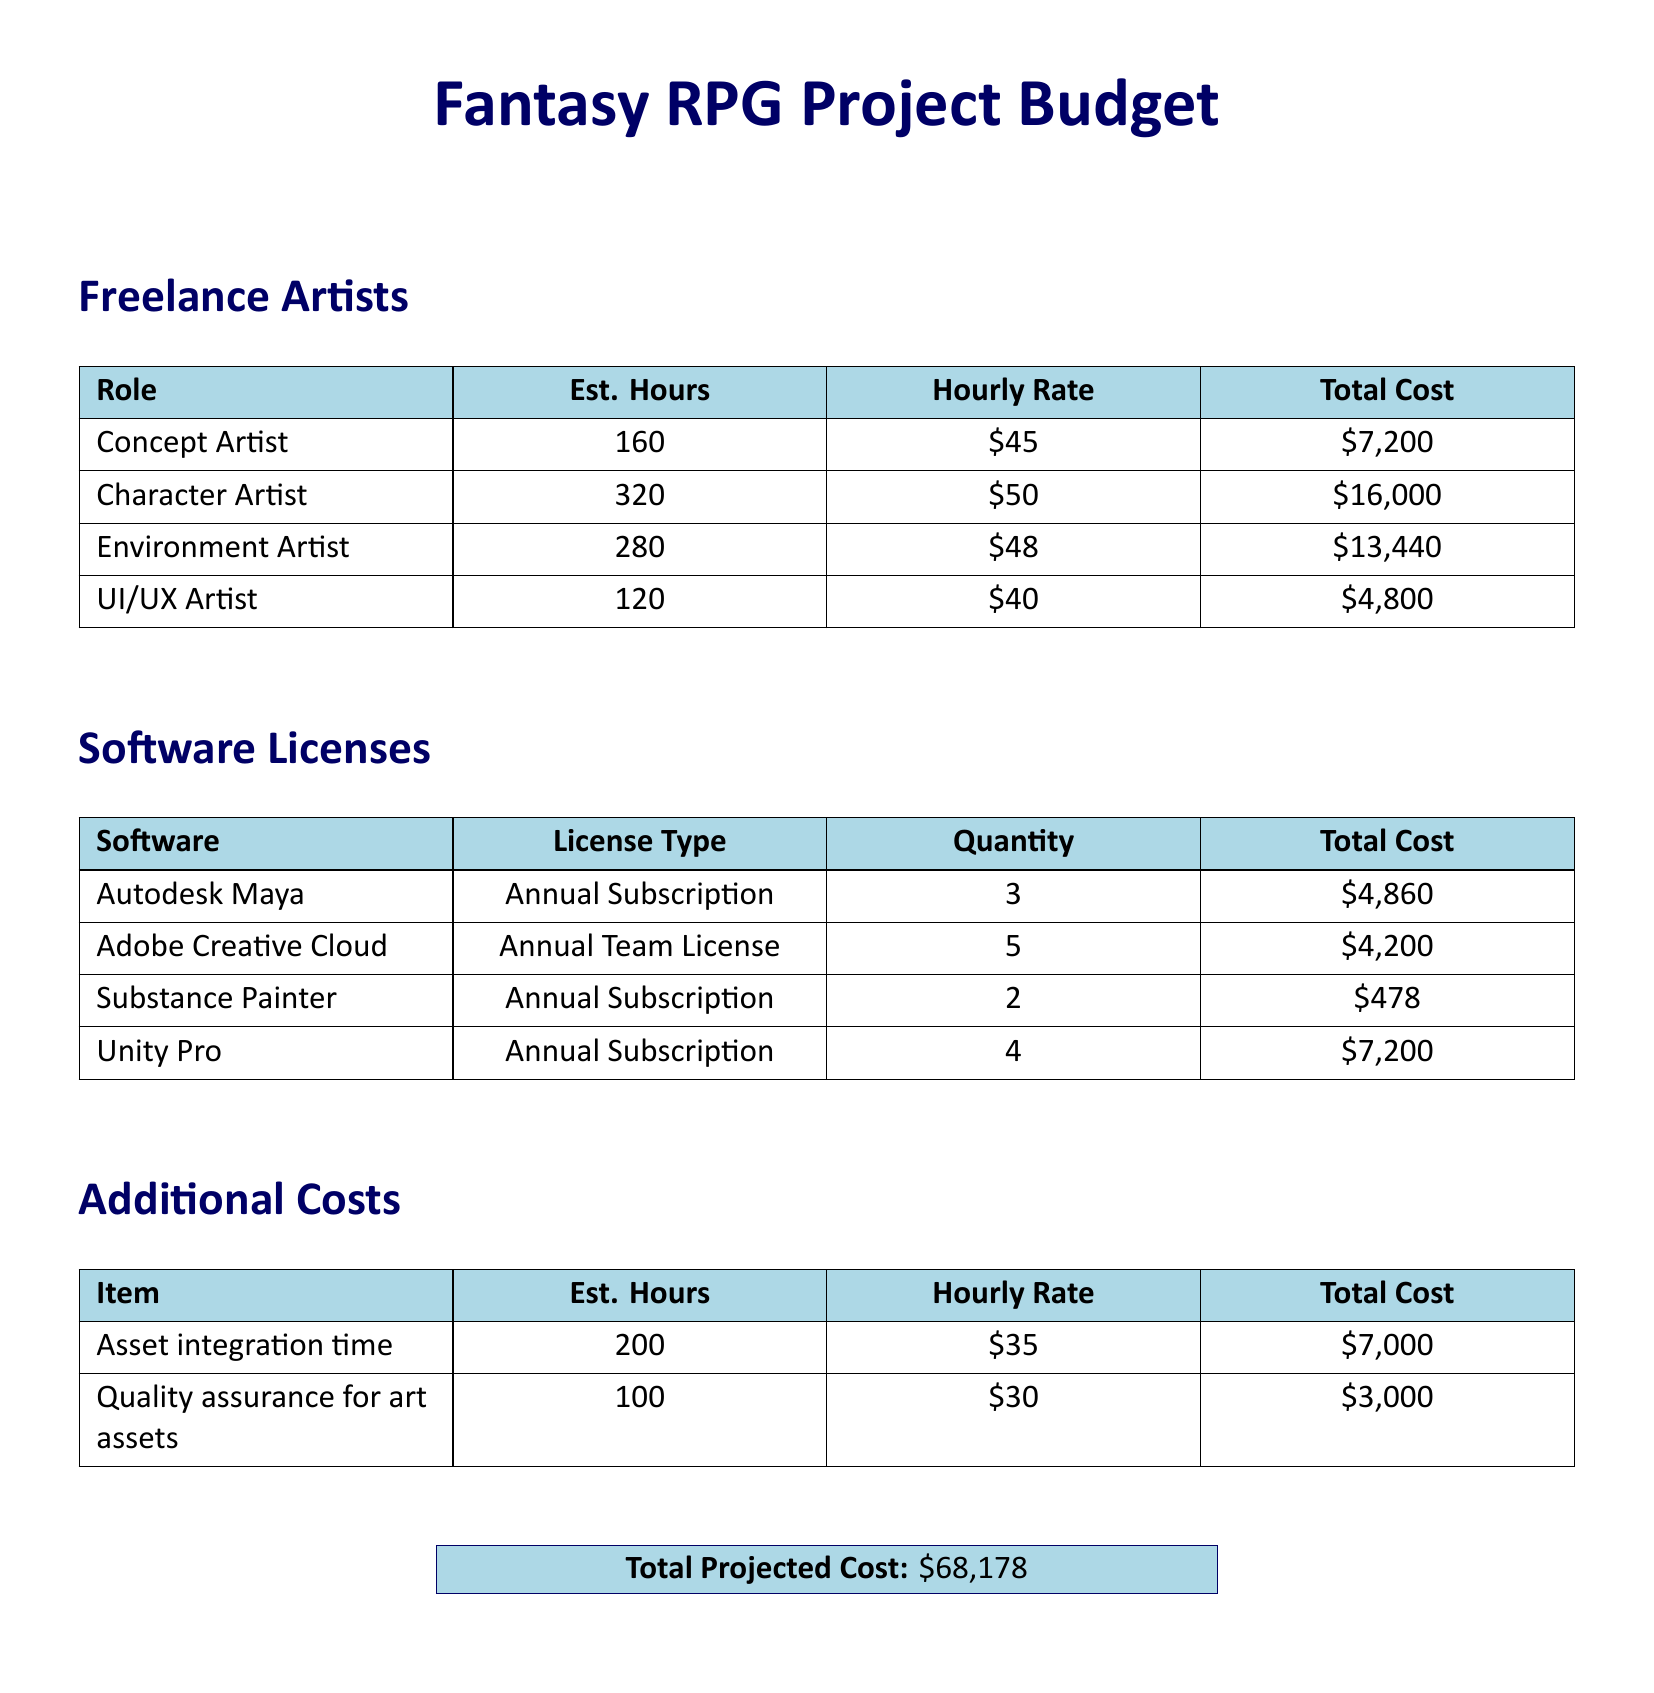What is the total cost for hiring a Character Artist? The total cost for hiring a Character Artist is found in the Freelance Artists section, which indicates 320 hours at an hourly rate of $50. So, 320 hours * $50 = $16,000.
Answer: $16,000 How many software licenses are required for Unity Pro? The quantity for Unity Pro is specified in the Software Licenses section of the document, which states that 4 licenses are needed.
Answer: 4 What is the hourly rate for a UI/UX Artist? The hourly rate for a UI/UX Artist is detailed in the Freelance Artists section, which shows it as $40 per hour.
Answer: $40 What is the total projected cost for the project? The total projected cost can be found at the bottom of the document, which sums all projected expenses to $68,178.
Answer: $68,178 How many Concept Artists are accounted for in the budget? The budget includes one Concept Artist's role, listed in the Freelance Artists section.
Answer: One What is the estimated total cost for Adobe Creative Cloud? The total cost for Adobe Creative Cloud is included in the Software Licenses section, where it is identified as $4,200.
Answer: $4,200 What is the estimated hourly rate for asset integration time? The hourly rate for asset integration, outlined in the Additional Costs section, is $35.
Answer: $35 What is the total cost for Substance Painter licenses? The total cost for Substance Painter is presented in the Software Licenses section, which states it as $478.
Answer: $478 What is the estimated number of hours required for quality assurance? The estimated number of hours for quality assurance is listed in the Additional Costs section, which indicates 100 hours.
Answer: 100 